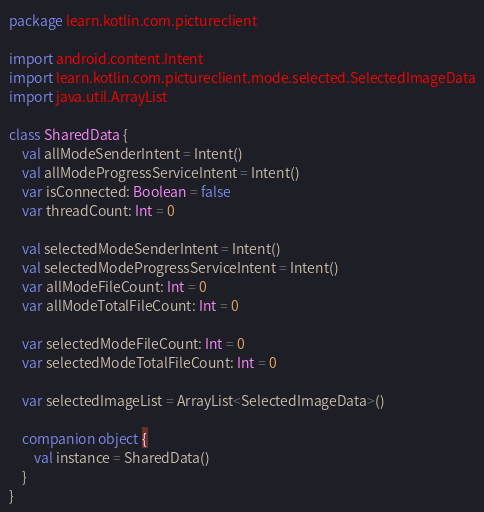<code> <loc_0><loc_0><loc_500><loc_500><_Kotlin_>package learn.kotlin.com.pictureclient

import android.content.Intent
import learn.kotlin.com.pictureclient.mode.selected.SelectedImageData
import java.util.ArrayList

class SharedData {
    val allModeSenderIntent = Intent()
    val allModeProgressServiceIntent = Intent()
    var isConnected: Boolean = false
    var threadCount: Int = 0

    val selectedModeSenderIntent = Intent()
    val selectedModeProgressServiceIntent = Intent()
    var allModeFileCount: Int = 0
    var allModeTotalFileCount: Int = 0

    var selectedModeFileCount: Int = 0
    var selectedModeTotalFileCount: Int = 0

    var selectedImageList = ArrayList<SelectedImageData>()

    companion object {
        val instance = SharedData()
    }
}</code> 